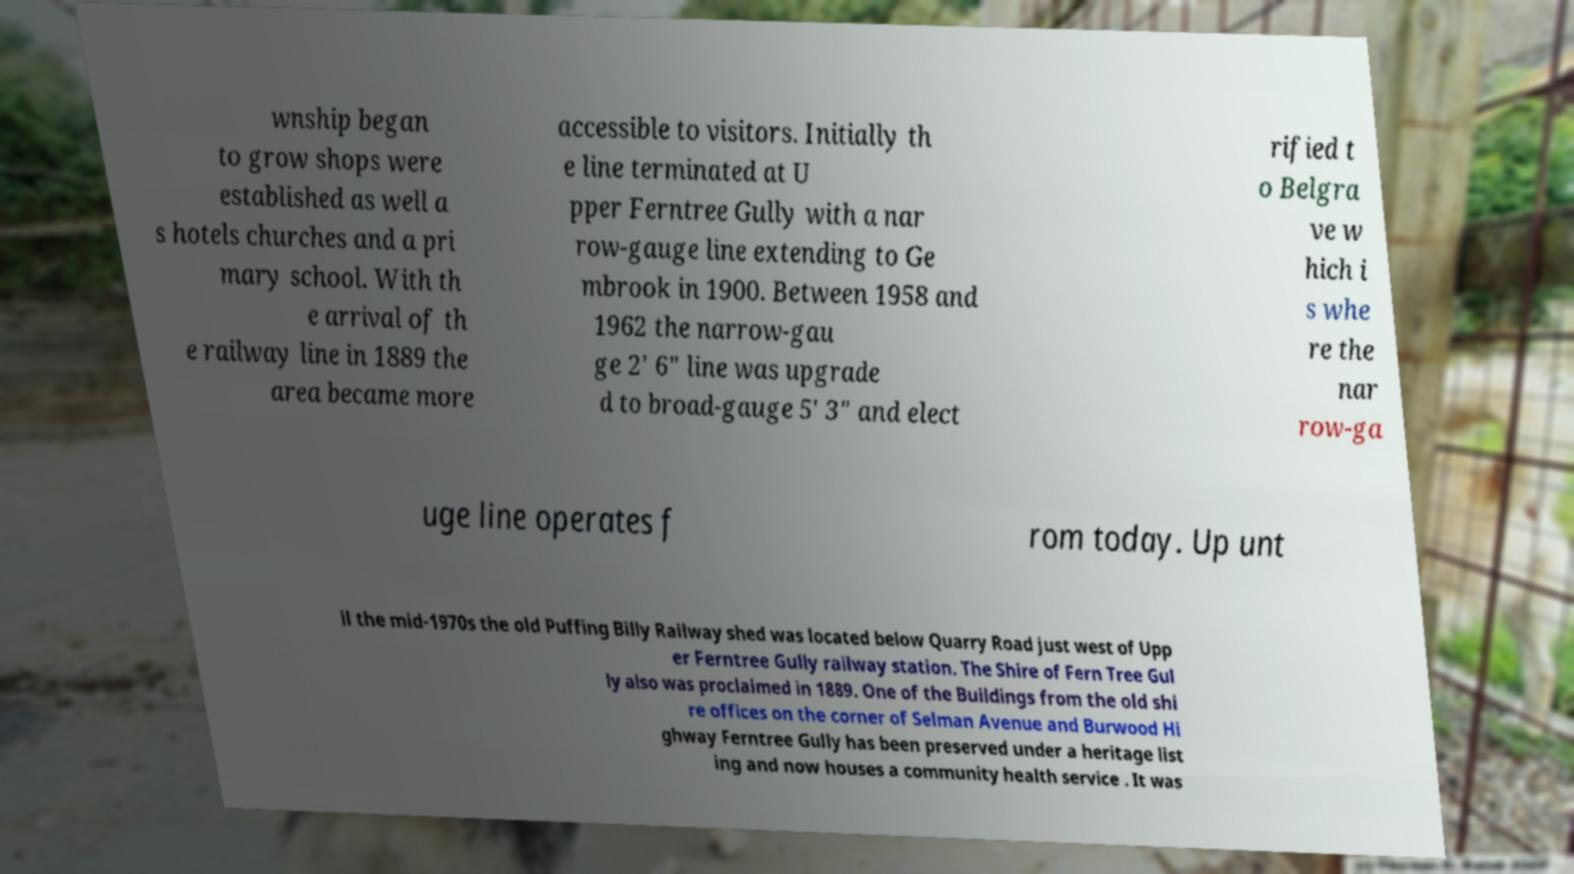I need the written content from this picture converted into text. Can you do that? wnship began to grow shops were established as well a s hotels churches and a pri mary school. With th e arrival of th e railway line in 1889 the area became more accessible to visitors. Initially th e line terminated at U pper Ferntree Gully with a nar row-gauge line extending to Ge mbrook in 1900. Between 1958 and 1962 the narrow-gau ge 2' 6" line was upgrade d to broad-gauge 5' 3" and elect rified t o Belgra ve w hich i s whe re the nar row-ga uge line operates f rom today. Up unt il the mid-1970s the old Puffing Billy Railway shed was located below Quarry Road just west of Upp er Ferntree Gully railway station. The Shire of Fern Tree Gul ly also was proclaimed in 1889. One of the Buildings from the old shi re offices on the corner of Selman Avenue and Burwood Hi ghway Ferntree Gully has been preserved under a heritage list ing and now houses a community health service . It was 